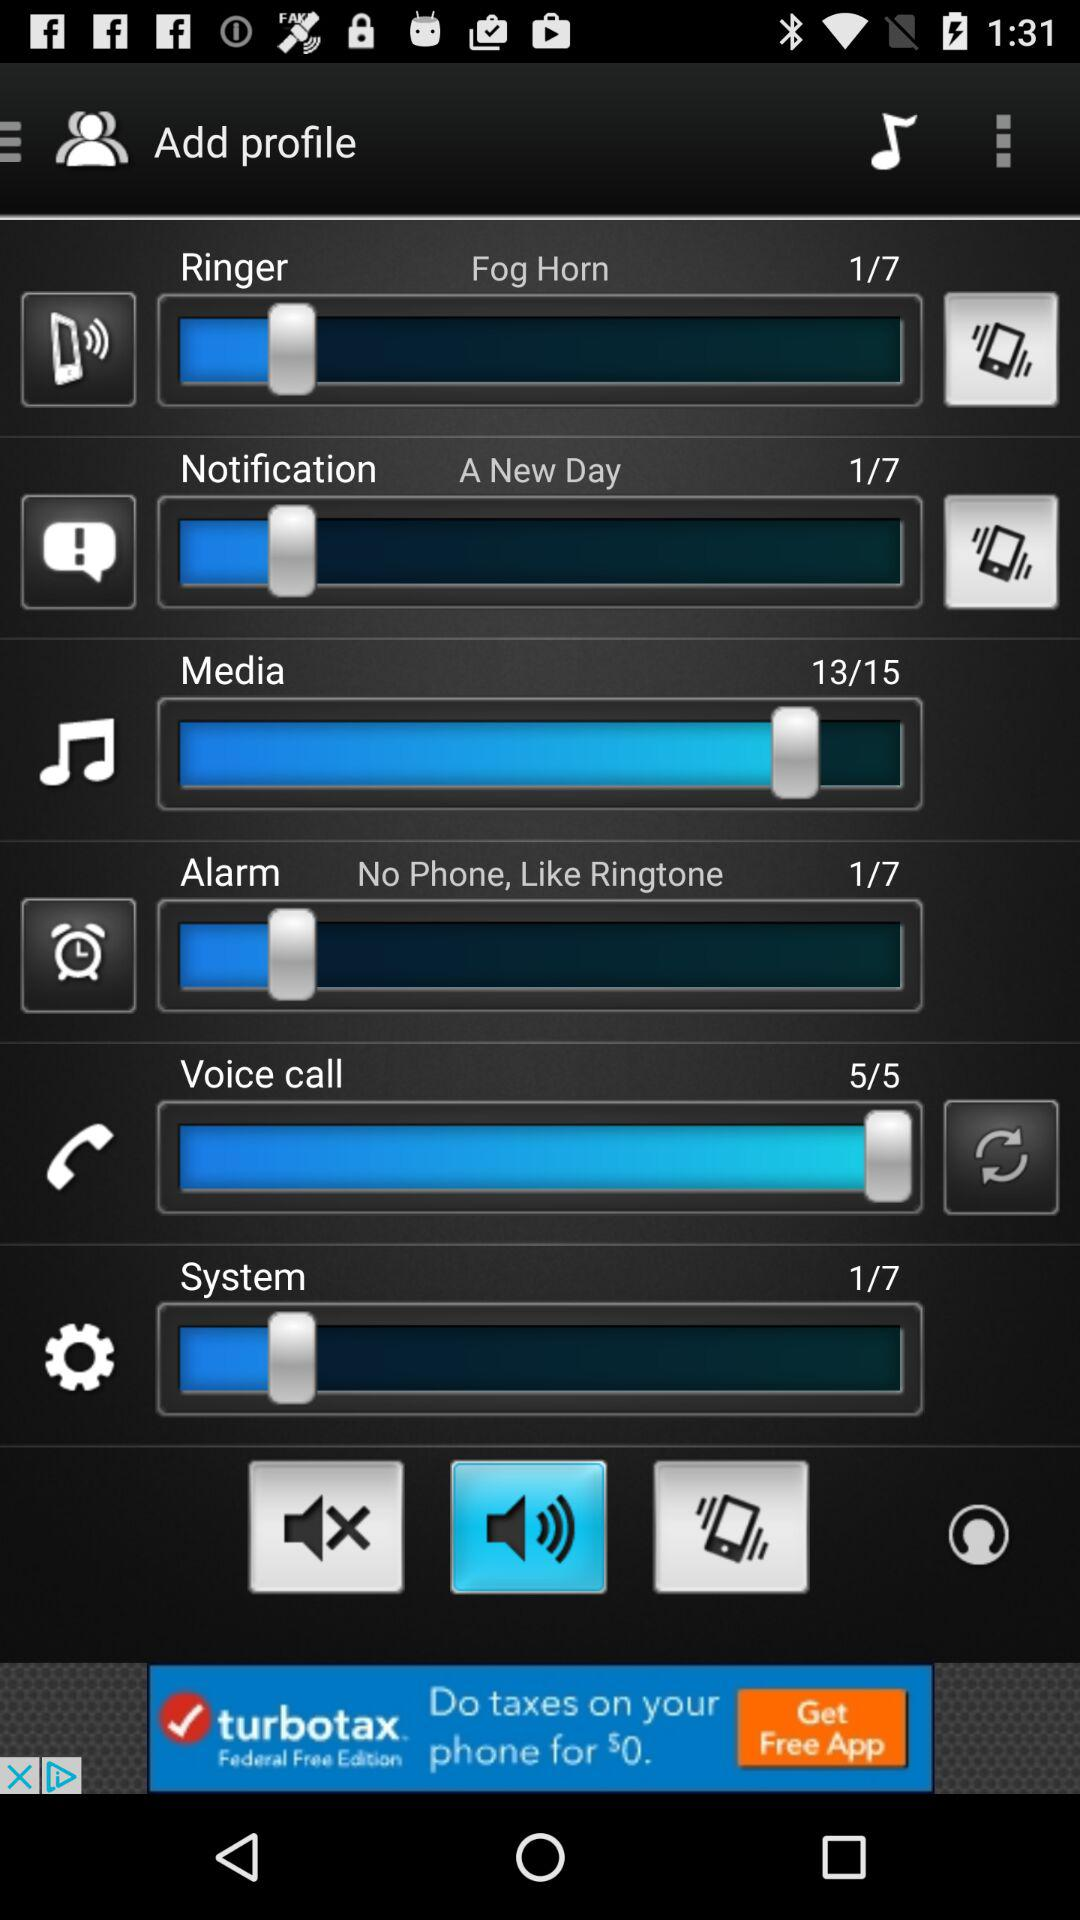What is the volume level for the ringer? The volume level is 1. 